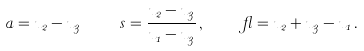Convert formula to latex. <formula><loc_0><loc_0><loc_500><loc_500>a = u _ { 2 } - u _ { 3 } \, \quad \, s = \frac { u _ { 2 } - u _ { 3 } } { u _ { 1 } - u _ { 3 } } \, , \quad \, \gamma = u _ { 2 } + u _ { 3 } - u _ { 1 } \, .</formula> 